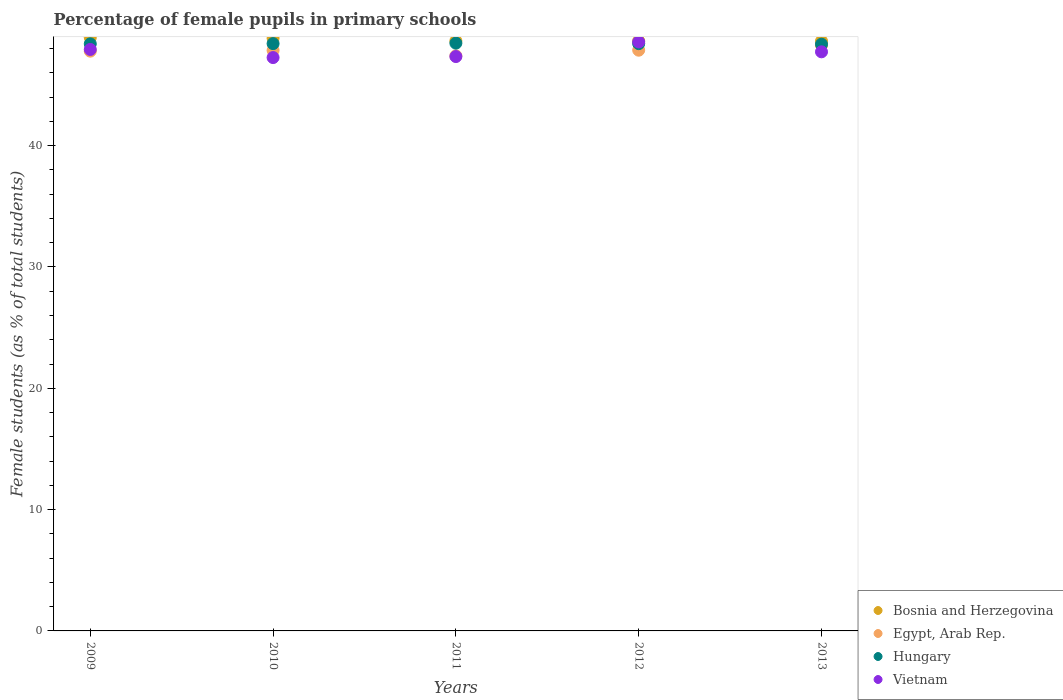How many different coloured dotlines are there?
Ensure brevity in your answer.  4. Is the number of dotlines equal to the number of legend labels?
Keep it short and to the point. Yes. What is the percentage of female pupils in primary schools in Bosnia and Herzegovina in 2012?
Give a very brief answer. 48.63. Across all years, what is the maximum percentage of female pupils in primary schools in Bosnia and Herzegovina?
Your answer should be compact. 48.91. Across all years, what is the minimum percentage of female pupils in primary schools in Bosnia and Herzegovina?
Keep it short and to the point. 48.61. In which year was the percentage of female pupils in primary schools in Egypt, Arab Rep. minimum?
Your answer should be very brief. 2011. What is the total percentage of female pupils in primary schools in Vietnam in the graph?
Your response must be concise. 238.83. What is the difference between the percentage of female pupils in primary schools in Vietnam in 2009 and that in 2011?
Your answer should be compact. 0.59. What is the difference between the percentage of female pupils in primary schools in Hungary in 2013 and the percentage of female pupils in primary schools in Egypt, Arab Rep. in 2009?
Your answer should be compact. 0.57. What is the average percentage of female pupils in primary schools in Egypt, Arab Rep. per year?
Ensure brevity in your answer.  47.84. In the year 2012, what is the difference between the percentage of female pupils in primary schools in Egypt, Arab Rep. and percentage of female pupils in primary schools in Bosnia and Herzegovina?
Ensure brevity in your answer.  -0.76. What is the ratio of the percentage of female pupils in primary schools in Hungary in 2011 to that in 2013?
Your answer should be very brief. 1. Is the percentage of female pupils in primary schools in Egypt, Arab Rep. in 2010 less than that in 2011?
Ensure brevity in your answer.  No. Is the difference between the percentage of female pupils in primary schools in Egypt, Arab Rep. in 2011 and 2013 greater than the difference between the percentage of female pupils in primary schools in Bosnia and Herzegovina in 2011 and 2013?
Give a very brief answer. No. What is the difference between the highest and the second highest percentage of female pupils in primary schools in Egypt, Arab Rep.?
Your answer should be very brief. 0.4. What is the difference between the highest and the lowest percentage of female pupils in primary schools in Egypt, Arab Rep.?
Give a very brief answer. 0.87. Is it the case that in every year, the sum of the percentage of female pupils in primary schools in Bosnia and Herzegovina and percentage of female pupils in primary schools in Egypt, Arab Rep.  is greater than the sum of percentage of female pupils in primary schools in Hungary and percentage of female pupils in primary schools in Vietnam?
Your response must be concise. No. Is it the case that in every year, the sum of the percentage of female pupils in primary schools in Hungary and percentage of female pupils in primary schools in Bosnia and Herzegovina  is greater than the percentage of female pupils in primary schools in Egypt, Arab Rep.?
Offer a terse response. Yes. Is the percentage of female pupils in primary schools in Egypt, Arab Rep. strictly less than the percentage of female pupils in primary schools in Bosnia and Herzegovina over the years?
Your response must be concise. Yes. How many years are there in the graph?
Provide a short and direct response. 5. Are the values on the major ticks of Y-axis written in scientific E-notation?
Offer a terse response. No. Does the graph contain any zero values?
Provide a succinct answer. No. Does the graph contain grids?
Give a very brief answer. No. How are the legend labels stacked?
Ensure brevity in your answer.  Vertical. What is the title of the graph?
Offer a terse response. Percentage of female pupils in primary schools. What is the label or title of the Y-axis?
Offer a very short reply. Female students (as % of total students). What is the Female students (as % of total students) in Bosnia and Herzegovina in 2009?
Ensure brevity in your answer.  48.91. What is the Female students (as % of total students) of Egypt, Arab Rep. in 2009?
Give a very brief answer. 47.79. What is the Female students (as % of total students) in Hungary in 2009?
Provide a short and direct response. 48.39. What is the Female students (as % of total students) of Vietnam in 2009?
Offer a terse response. 47.93. What is the Female students (as % of total students) in Bosnia and Herzegovina in 2010?
Your answer should be very brief. 48.86. What is the Female students (as % of total students) of Egypt, Arab Rep. in 2010?
Ensure brevity in your answer.  47.85. What is the Female students (as % of total students) in Hungary in 2010?
Make the answer very short. 48.41. What is the Female students (as % of total students) of Vietnam in 2010?
Offer a very short reply. 47.26. What is the Female students (as % of total students) of Bosnia and Herzegovina in 2011?
Provide a succinct answer. 48.63. What is the Female students (as % of total students) of Egypt, Arab Rep. in 2011?
Ensure brevity in your answer.  47.4. What is the Female students (as % of total students) in Hungary in 2011?
Ensure brevity in your answer.  48.45. What is the Female students (as % of total students) of Vietnam in 2011?
Provide a short and direct response. 47.35. What is the Female students (as % of total students) in Bosnia and Herzegovina in 2012?
Make the answer very short. 48.63. What is the Female students (as % of total students) of Egypt, Arab Rep. in 2012?
Your response must be concise. 47.87. What is the Female students (as % of total students) in Hungary in 2012?
Provide a short and direct response. 48.41. What is the Female students (as % of total students) in Vietnam in 2012?
Offer a terse response. 48.55. What is the Female students (as % of total students) in Bosnia and Herzegovina in 2013?
Make the answer very short. 48.61. What is the Female students (as % of total students) in Egypt, Arab Rep. in 2013?
Provide a succinct answer. 48.27. What is the Female students (as % of total students) of Hungary in 2013?
Ensure brevity in your answer.  48.36. What is the Female students (as % of total students) in Vietnam in 2013?
Make the answer very short. 47.74. Across all years, what is the maximum Female students (as % of total students) in Bosnia and Herzegovina?
Make the answer very short. 48.91. Across all years, what is the maximum Female students (as % of total students) in Egypt, Arab Rep.?
Provide a succinct answer. 48.27. Across all years, what is the maximum Female students (as % of total students) of Hungary?
Provide a succinct answer. 48.45. Across all years, what is the maximum Female students (as % of total students) in Vietnam?
Ensure brevity in your answer.  48.55. Across all years, what is the minimum Female students (as % of total students) in Bosnia and Herzegovina?
Keep it short and to the point. 48.61. Across all years, what is the minimum Female students (as % of total students) of Egypt, Arab Rep.?
Keep it short and to the point. 47.4. Across all years, what is the minimum Female students (as % of total students) of Hungary?
Keep it short and to the point. 48.36. Across all years, what is the minimum Female students (as % of total students) of Vietnam?
Your response must be concise. 47.26. What is the total Female students (as % of total students) in Bosnia and Herzegovina in the graph?
Your response must be concise. 243.65. What is the total Female students (as % of total students) in Egypt, Arab Rep. in the graph?
Make the answer very short. 239.19. What is the total Female students (as % of total students) of Hungary in the graph?
Provide a short and direct response. 242.03. What is the total Female students (as % of total students) of Vietnam in the graph?
Your response must be concise. 238.83. What is the difference between the Female students (as % of total students) of Bosnia and Herzegovina in 2009 and that in 2010?
Provide a succinct answer. 0.05. What is the difference between the Female students (as % of total students) in Egypt, Arab Rep. in 2009 and that in 2010?
Provide a short and direct response. -0.06. What is the difference between the Female students (as % of total students) of Hungary in 2009 and that in 2010?
Offer a terse response. -0.02. What is the difference between the Female students (as % of total students) in Vietnam in 2009 and that in 2010?
Provide a succinct answer. 0.67. What is the difference between the Female students (as % of total students) in Bosnia and Herzegovina in 2009 and that in 2011?
Offer a terse response. 0.28. What is the difference between the Female students (as % of total students) of Egypt, Arab Rep. in 2009 and that in 2011?
Your answer should be compact. 0.39. What is the difference between the Female students (as % of total students) of Hungary in 2009 and that in 2011?
Your answer should be very brief. -0.06. What is the difference between the Female students (as % of total students) of Vietnam in 2009 and that in 2011?
Offer a very short reply. 0.59. What is the difference between the Female students (as % of total students) in Bosnia and Herzegovina in 2009 and that in 2012?
Your response must be concise. 0.28. What is the difference between the Female students (as % of total students) of Egypt, Arab Rep. in 2009 and that in 2012?
Give a very brief answer. -0.08. What is the difference between the Female students (as % of total students) of Hungary in 2009 and that in 2012?
Provide a succinct answer. -0.02. What is the difference between the Female students (as % of total students) of Vietnam in 2009 and that in 2012?
Keep it short and to the point. -0.62. What is the difference between the Female students (as % of total students) in Bosnia and Herzegovina in 2009 and that in 2013?
Provide a succinct answer. 0.3. What is the difference between the Female students (as % of total students) in Egypt, Arab Rep. in 2009 and that in 2013?
Provide a short and direct response. -0.48. What is the difference between the Female students (as % of total students) in Hungary in 2009 and that in 2013?
Give a very brief answer. 0.03. What is the difference between the Female students (as % of total students) of Vietnam in 2009 and that in 2013?
Keep it short and to the point. 0.2. What is the difference between the Female students (as % of total students) in Bosnia and Herzegovina in 2010 and that in 2011?
Keep it short and to the point. 0.23. What is the difference between the Female students (as % of total students) in Egypt, Arab Rep. in 2010 and that in 2011?
Your response must be concise. 0.45. What is the difference between the Female students (as % of total students) of Hungary in 2010 and that in 2011?
Your answer should be very brief. -0.04. What is the difference between the Female students (as % of total students) in Vietnam in 2010 and that in 2011?
Provide a succinct answer. -0.08. What is the difference between the Female students (as % of total students) of Bosnia and Herzegovina in 2010 and that in 2012?
Offer a very short reply. 0.23. What is the difference between the Female students (as % of total students) in Egypt, Arab Rep. in 2010 and that in 2012?
Give a very brief answer. -0.02. What is the difference between the Female students (as % of total students) of Hungary in 2010 and that in 2012?
Give a very brief answer. 0. What is the difference between the Female students (as % of total students) of Vietnam in 2010 and that in 2012?
Provide a succinct answer. -1.29. What is the difference between the Female students (as % of total students) of Bosnia and Herzegovina in 2010 and that in 2013?
Your answer should be compact. 0.24. What is the difference between the Female students (as % of total students) in Egypt, Arab Rep. in 2010 and that in 2013?
Offer a terse response. -0.42. What is the difference between the Female students (as % of total students) of Hungary in 2010 and that in 2013?
Your response must be concise. 0.05. What is the difference between the Female students (as % of total students) in Vietnam in 2010 and that in 2013?
Offer a very short reply. -0.47. What is the difference between the Female students (as % of total students) of Bosnia and Herzegovina in 2011 and that in 2012?
Give a very brief answer. 0. What is the difference between the Female students (as % of total students) of Egypt, Arab Rep. in 2011 and that in 2012?
Provide a succinct answer. -0.47. What is the difference between the Female students (as % of total students) in Hungary in 2011 and that in 2012?
Provide a succinct answer. 0.04. What is the difference between the Female students (as % of total students) of Vietnam in 2011 and that in 2012?
Your answer should be compact. -1.2. What is the difference between the Female students (as % of total students) in Bosnia and Herzegovina in 2011 and that in 2013?
Your answer should be compact. 0.02. What is the difference between the Female students (as % of total students) of Egypt, Arab Rep. in 2011 and that in 2013?
Your response must be concise. -0.87. What is the difference between the Female students (as % of total students) of Hungary in 2011 and that in 2013?
Your answer should be very brief. 0.09. What is the difference between the Female students (as % of total students) of Vietnam in 2011 and that in 2013?
Offer a terse response. -0.39. What is the difference between the Female students (as % of total students) of Bosnia and Herzegovina in 2012 and that in 2013?
Keep it short and to the point. 0.02. What is the difference between the Female students (as % of total students) in Egypt, Arab Rep. in 2012 and that in 2013?
Offer a terse response. -0.4. What is the difference between the Female students (as % of total students) in Hungary in 2012 and that in 2013?
Your answer should be very brief. 0.05. What is the difference between the Female students (as % of total students) in Vietnam in 2012 and that in 2013?
Your answer should be compact. 0.82. What is the difference between the Female students (as % of total students) of Bosnia and Herzegovina in 2009 and the Female students (as % of total students) of Egypt, Arab Rep. in 2010?
Keep it short and to the point. 1.06. What is the difference between the Female students (as % of total students) in Bosnia and Herzegovina in 2009 and the Female students (as % of total students) in Hungary in 2010?
Offer a terse response. 0.5. What is the difference between the Female students (as % of total students) of Bosnia and Herzegovina in 2009 and the Female students (as % of total students) of Vietnam in 2010?
Make the answer very short. 1.65. What is the difference between the Female students (as % of total students) of Egypt, Arab Rep. in 2009 and the Female students (as % of total students) of Hungary in 2010?
Make the answer very short. -0.62. What is the difference between the Female students (as % of total students) in Egypt, Arab Rep. in 2009 and the Female students (as % of total students) in Vietnam in 2010?
Keep it short and to the point. 0.53. What is the difference between the Female students (as % of total students) in Hungary in 2009 and the Female students (as % of total students) in Vietnam in 2010?
Your answer should be compact. 1.13. What is the difference between the Female students (as % of total students) of Bosnia and Herzegovina in 2009 and the Female students (as % of total students) of Egypt, Arab Rep. in 2011?
Your response must be concise. 1.51. What is the difference between the Female students (as % of total students) of Bosnia and Herzegovina in 2009 and the Female students (as % of total students) of Hungary in 2011?
Your answer should be compact. 0.46. What is the difference between the Female students (as % of total students) in Bosnia and Herzegovina in 2009 and the Female students (as % of total students) in Vietnam in 2011?
Your answer should be compact. 1.56. What is the difference between the Female students (as % of total students) in Egypt, Arab Rep. in 2009 and the Female students (as % of total students) in Hungary in 2011?
Ensure brevity in your answer.  -0.66. What is the difference between the Female students (as % of total students) of Egypt, Arab Rep. in 2009 and the Female students (as % of total students) of Vietnam in 2011?
Offer a very short reply. 0.44. What is the difference between the Female students (as % of total students) in Hungary in 2009 and the Female students (as % of total students) in Vietnam in 2011?
Make the answer very short. 1.05. What is the difference between the Female students (as % of total students) in Bosnia and Herzegovina in 2009 and the Female students (as % of total students) in Egypt, Arab Rep. in 2012?
Provide a short and direct response. 1.04. What is the difference between the Female students (as % of total students) in Bosnia and Herzegovina in 2009 and the Female students (as % of total students) in Hungary in 2012?
Your response must be concise. 0.5. What is the difference between the Female students (as % of total students) of Bosnia and Herzegovina in 2009 and the Female students (as % of total students) of Vietnam in 2012?
Offer a very short reply. 0.36. What is the difference between the Female students (as % of total students) in Egypt, Arab Rep. in 2009 and the Female students (as % of total students) in Hungary in 2012?
Ensure brevity in your answer.  -0.62. What is the difference between the Female students (as % of total students) of Egypt, Arab Rep. in 2009 and the Female students (as % of total students) of Vietnam in 2012?
Offer a very short reply. -0.76. What is the difference between the Female students (as % of total students) of Hungary in 2009 and the Female students (as % of total students) of Vietnam in 2012?
Ensure brevity in your answer.  -0.16. What is the difference between the Female students (as % of total students) of Bosnia and Herzegovina in 2009 and the Female students (as % of total students) of Egypt, Arab Rep. in 2013?
Provide a succinct answer. 0.64. What is the difference between the Female students (as % of total students) in Bosnia and Herzegovina in 2009 and the Female students (as % of total students) in Hungary in 2013?
Provide a short and direct response. 0.55. What is the difference between the Female students (as % of total students) in Bosnia and Herzegovina in 2009 and the Female students (as % of total students) in Vietnam in 2013?
Keep it short and to the point. 1.17. What is the difference between the Female students (as % of total students) in Egypt, Arab Rep. in 2009 and the Female students (as % of total students) in Hungary in 2013?
Provide a succinct answer. -0.57. What is the difference between the Female students (as % of total students) of Egypt, Arab Rep. in 2009 and the Female students (as % of total students) of Vietnam in 2013?
Offer a very short reply. 0.06. What is the difference between the Female students (as % of total students) of Hungary in 2009 and the Female students (as % of total students) of Vietnam in 2013?
Make the answer very short. 0.66. What is the difference between the Female students (as % of total students) of Bosnia and Herzegovina in 2010 and the Female students (as % of total students) of Egypt, Arab Rep. in 2011?
Provide a short and direct response. 1.46. What is the difference between the Female students (as % of total students) in Bosnia and Herzegovina in 2010 and the Female students (as % of total students) in Hungary in 2011?
Give a very brief answer. 0.41. What is the difference between the Female students (as % of total students) in Bosnia and Herzegovina in 2010 and the Female students (as % of total students) in Vietnam in 2011?
Offer a terse response. 1.51. What is the difference between the Female students (as % of total students) of Egypt, Arab Rep. in 2010 and the Female students (as % of total students) of Hungary in 2011?
Keep it short and to the point. -0.6. What is the difference between the Female students (as % of total students) in Egypt, Arab Rep. in 2010 and the Female students (as % of total students) in Vietnam in 2011?
Give a very brief answer. 0.51. What is the difference between the Female students (as % of total students) in Hungary in 2010 and the Female students (as % of total students) in Vietnam in 2011?
Provide a short and direct response. 1.07. What is the difference between the Female students (as % of total students) in Bosnia and Herzegovina in 2010 and the Female students (as % of total students) in Egypt, Arab Rep. in 2012?
Your answer should be very brief. 0.99. What is the difference between the Female students (as % of total students) of Bosnia and Herzegovina in 2010 and the Female students (as % of total students) of Hungary in 2012?
Keep it short and to the point. 0.45. What is the difference between the Female students (as % of total students) of Bosnia and Herzegovina in 2010 and the Female students (as % of total students) of Vietnam in 2012?
Your answer should be very brief. 0.31. What is the difference between the Female students (as % of total students) of Egypt, Arab Rep. in 2010 and the Female students (as % of total students) of Hungary in 2012?
Give a very brief answer. -0.56. What is the difference between the Female students (as % of total students) in Egypt, Arab Rep. in 2010 and the Female students (as % of total students) in Vietnam in 2012?
Your answer should be very brief. -0.7. What is the difference between the Female students (as % of total students) in Hungary in 2010 and the Female students (as % of total students) in Vietnam in 2012?
Ensure brevity in your answer.  -0.14. What is the difference between the Female students (as % of total students) in Bosnia and Herzegovina in 2010 and the Female students (as % of total students) in Egypt, Arab Rep. in 2013?
Your response must be concise. 0.59. What is the difference between the Female students (as % of total students) in Bosnia and Herzegovina in 2010 and the Female students (as % of total students) in Hungary in 2013?
Make the answer very short. 0.49. What is the difference between the Female students (as % of total students) in Bosnia and Herzegovina in 2010 and the Female students (as % of total students) in Vietnam in 2013?
Your answer should be compact. 1.12. What is the difference between the Female students (as % of total students) of Egypt, Arab Rep. in 2010 and the Female students (as % of total students) of Hungary in 2013?
Ensure brevity in your answer.  -0.51. What is the difference between the Female students (as % of total students) of Egypt, Arab Rep. in 2010 and the Female students (as % of total students) of Vietnam in 2013?
Offer a very short reply. 0.12. What is the difference between the Female students (as % of total students) of Hungary in 2010 and the Female students (as % of total students) of Vietnam in 2013?
Your answer should be very brief. 0.68. What is the difference between the Female students (as % of total students) of Bosnia and Herzegovina in 2011 and the Female students (as % of total students) of Egypt, Arab Rep. in 2012?
Offer a terse response. 0.76. What is the difference between the Female students (as % of total students) in Bosnia and Herzegovina in 2011 and the Female students (as % of total students) in Hungary in 2012?
Keep it short and to the point. 0.22. What is the difference between the Female students (as % of total students) of Bosnia and Herzegovina in 2011 and the Female students (as % of total students) of Vietnam in 2012?
Provide a succinct answer. 0.08. What is the difference between the Female students (as % of total students) in Egypt, Arab Rep. in 2011 and the Female students (as % of total students) in Hungary in 2012?
Offer a terse response. -1.01. What is the difference between the Female students (as % of total students) in Egypt, Arab Rep. in 2011 and the Female students (as % of total students) in Vietnam in 2012?
Offer a terse response. -1.15. What is the difference between the Female students (as % of total students) of Hungary in 2011 and the Female students (as % of total students) of Vietnam in 2012?
Ensure brevity in your answer.  -0.1. What is the difference between the Female students (as % of total students) in Bosnia and Herzegovina in 2011 and the Female students (as % of total students) in Egypt, Arab Rep. in 2013?
Ensure brevity in your answer.  0.36. What is the difference between the Female students (as % of total students) of Bosnia and Herzegovina in 2011 and the Female students (as % of total students) of Hungary in 2013?
Provide a succinct answer. 0.27. What is the difference between the Female students (as % of total students) in Bosnia and Herzegovina in 2011 and the Female students (as % of total students) in Vietnam in 2013?
Give a very brief answer. 0.9. What is the difference between the Female students (as % of total students) in Egypt, Arab Rep. in 2011 and the Female students (as % of total students) in Hungary in 2013?
Your answer should be very brief. -0.96. What is the difference between the Female students (as % of total students) of Egypt, Arab Rep. in 2011 and the Female students (as % of total students) of Vietnam in 2013?
Ensure brevity in your answer.  -0.33. What is the difference between the Female students (as % of total students) of Hungary in 2011 and the Female students (as % of total students) of Vietnam in 2013?
Ensure brevity in your answer.  0.71. What is the difference between the Female students (as % of total students) of Bosnia and Herzegovina in 2012 and the Female students (as % of total students) of Egypt, Arab Rep. in 2013?
Provide a short and direct response. 0.36. What is the difference between the Female students (as % of total students) of Bosnia and Herzegovina in 2012 and the Female students (as % of total students) of Hungary in 2013?
Offer a very short reply. 0.27. What is the difference between the Female students (as % of total students) of Bosnia and Herzegovina in 2012 and the Female students (as % of total students) of Vietnam in 2013?
Keep it short and to the point. 0.89. What is the difference between the Female students (as % of total students) in Egypt, Arab Rep. in 2012 and the Female students (as % of total students) in Hungary in 2013?
Provide a short and direct response. -0.49. What is the difference between the Female students (as % of total students) of Egypt, Arab Rep. in 2012 and the Female students (as % of total students) of Vietnam in 2013?
Provide a short and direct response. 0.13. What is the difference between the Female students (as % of total students) in Hungary in 2012 and the Female students (as % of total students) in Vietnam in 2013?
Ensure brevity in your answer.  0.67. What is the average Female students (as % of total students) in Bosnia and Herzegovina per year?
Ensure brevity in your answer.  48.73. What is the average Female students (as % of total students) of Egypt, Arab Rep. per year?
Keep it short and to the point. 47.84. What is the average Female students (as % of total students) of Hungary per year?
Provide a succinct answer. 48.41. What is the average Female students (as % of total students) of Vietnam per year?
Provide a short and direct response. 47.77. In the year 2009, what is the difference between the Female students (as % of total students) in Bosnia and Herzegovina and Female students (as % of total students) in Egypt, Arab Rep.?
Your answer should be very brief. 1.12. In the year 2009, what is the difference between the Female students (as % of total students) of Bosnia and Herzegovina and Female students (as % of total students) of Hungary?
Your answer should be very brief. 0.52. In the year 2009, what is the difference between the Female students (as % of total students) of Bosnia and Herzegovina and Female students (as % of total students) of Vietnam?
Your answer should be compact. 0.98. In the year 2009, what is the difference between the Female students (as % of total students) in Egypt, Arab Rep. and Female students (as % of total students) in Hungary?
Offer a very short reply. -0.6. In the year 2009, what is the difference between the Female students (as % of total students) in Egypt, Arab Rep. and Female students (as % of total students) in Vietnam?
Give a very brief answer. -0.14. In the year 2009, what is the difference between the Female students (as % of total students) in Hungary and Female students (as % of total students) in Vietnam?
Offer a terse response. 0.46. In the year 2010, what is the difference between the Female students (as % of total students) of Bosnia and Herzegovina and Female students (as % of total students) of Egypt, Arab Rep.?
Provide a succinct answer. 1.01. In the year 2010, what is the difference between the Female students (as % of total students) of Bosnia and Herzegovina and Female students (as % of total students) of Hungary?
Offer a very short reply. 0.45. In the year 2010, what is the difference between the Female students (as % of total students) of Bosnia and Herzegovina and Female students (as % of total students) of Vietnam?
Ensure brevity in your answer.  1.6. In the year 2010, what is the difference between the Female students (as % of total students) in Egypt, Arab Rep. and Female students (as % of total students) in Hungary?
Your response must be concise. -0.56. In the year 2010, what is the difference between the Female students (as % of total students) in Egypt, Arab Rep. and Female students (as % of total students) in Vietnam?
Your answer should be compact. 0.59. In the year 2010, what is the difference between the Female students (as % of total students) of Hungary and Female students (as % of total students) of Vietnam?
Ensure brevity in your answer.  1.15. In the year 2011, what is the difference between the Female students (as % of total students) in Bosnia and Herzegovina and Female students (as % of total students) in Egypt, Arab Rep.?
Ensure brevity in your answer.  1.23. In the year 2011, what is the difference between the Female students (as % of total students) in Bosnia and Herzegovina and Female students (as % of total students) in Hungary?
Offer a terse response. 0.18. In the year 2011, what is the difference between the Female students (as % of total students) of Bosnia and Herzegovina and Female students (as % of total students) of Vietnam?
Keep it short and to the point. 1.29. In the year 2011, what is the difference between the Female students (as % of total students) of Egypt, Arab Rep. and Female students (as % of total students) of Hungary?
Offer a very short reply. -1.05. In the year 2011, what is the difference between the Female students (as % of total students) of Egypt, Arab Rep. and Female students (as % of total students) of Vietnam?
Keep it short and to the point. 0.06. In the year 2011, what is the difference between the Female students (as % of total students) in Hungary and Female students (as % of total students) in Vietnam?
Provide a short and direct response. 1.1. In the year 2012, what is the difference between the Female students (as % of total students) of Bosnia and Herzegovina and Female students (as % of total students) of Egypt, Arab Rep.?
Offer a very short reply. 0.76. In the year 2012, what is the difference between the Female students (as % of total students) of Bosnia and Herzegovina and Female students (as % of total students) of Hungary?
Keep it short and to the point. 0.22. In the year 2012, what is the difference between the Female students (as % of total students) of Bosnia and Herzegovina and Female students (as % of total students) of Vietnam?
Your response must be concise. 0.08. In the year 2012, what is the difference between the Female students (as % of total students) of Egypt, Arab Rep. and Female students (as % of total students) of Hungary?
Your answer should be very brief. -0.54. In the year 2012, what is the difference between the Female students (as % of total students) of Egypt, Arab Rep. and Female students (as % of total students) of Vietnam?
Provide a short and direct response. -0.68. In the year 2012, what is the difference between the Female students (as % of total students) of Hungary and Female students (as % of total students) of Vietnam?
Make the answer very short. -0.14. In the year 2013, what is the difference between the Female students (as % of total students) of Bosnia and Herzegovina and Female students (as % of total students) of Egypt, Arab Rep.?
Make the answer very short. 0.34. In the year 2013, what is the difference between the Female students (as % of total students) in Bosnia and Herzegovina and Female students (as % of total students) in Hungary?
Make the answer very short. 0.25. In the year 2013, what is the difference between the Female students (as % of total students) in Bosnia and Herzegovina and Female students (as % of total students) in Vietnam?
Make the answer very short. 0.88. In the year 2013, what is the difference between the Female students (as % of total students) of Egypt, Arab Rep. and Female students (as % of total students) of Hungary?
Offer a terse response. -0.09. In the year 2013, what is the difference between the Female students (as % of total students) in Egypt, Arab Rep. and Female students (as % of total students) in Vietnam?
Offer a terse response. 0.54. In the year 2013, what is the difference between the Female students (as % of total students) of Hungary and Female students (as % of total students) of Vietnam?
Your answer should be very brief. 0.63. What is the ratio of the Female students (as % of total students) of Bosnia and Herzegovina in 2009 to that in 2010?
Give a very brief answer. 1. What is the ratio of the Female students (as % of total students) in Egypt, Arab Rep. in 2009 to that in 2010?
Your response must be concise. 1. What is the ratio of the Female students (as % of total students) in Vietnam in 2009 to that in 2010?
Your answer should be compact. 1.01. What is the ratio of the Female students (as % of total students) of Egypt, Arab Rep. in 2009 to that in 2011?
Offer a very short reply. 1.01. What is the ratio of the Female students (as % of total students) of Vietnam in 2009 to that in 2011?
Keep it short and to the point. 1.01. What is the ratio of the Female students (as % of total students) of Hungary in 2009 to that in 2012?
Offer a terse response. 1. What is the ratio of the Female students (as % of total students) in Vietnam in 2009 to that in 2012?
Offer a very short reply. 0.99. What is the ratio of the Female students (as % of total students) of Egypt, Arab Rep. in 2009 to that in 2013?
Give a very brief answer. 0.99. What is the ratio of the Female students (as % of total students) of Vietnam in 2009 to that in 2013?
Your response must be concise. 1. What is the ratio of the Female students (as % of total students) in Bosnia and Herzegovina in 2010 to that in 2011?
Your response must be concise. 1. What is the ratio of the Female students (as % of total students) of Egypt, Arab Rep. in 2010 to that in 2011?
Ensure brevity in your answer.  1.01. What is the ratio of the Female students (as % of total students) in Hungary in 2010 to that in 2011?
Provide a succinct answer. 1. What is the ratio of the Female students (as % of total students) of Bosnia and Herzegovina in 2010 to that in 2012?
Give a very brief answer. 1. What is the ratio of the Female students (as % of total students) of Egypt, Arab Rep. in 2010 to that in 2012?
Provide a short and direct response. 1. What is the ratio of the Female students (as % of total students) in Vietnam in 2010 to that in 2012?
Provide a succinct answer. 0.97. What is the ratio of the Female students (as % of total students) of Egypt, Arab Rep. in 2010 to that in 2013?
Provide a succinct answer. 0.99. What is the ratio of the Female students (as % of total students) in Vietnam in 2010 to that in 2013?
Offer a terse response. 0.99. What is the ratio of the Female students (as % of total students) in Bosnia and Herzegovina in 2011 to that in 2012?
Make the answer very short. 1. What is the ratio of the Female students (as % of total students) of Egypt, Arab Rep. in 2011 to that in 2012?
Give a very brief answer. 0.99. What is the ratio of the Female students (as % of total students) in Hungary in 2011 to that in 2012?
Provide a succinct answer. 1. What is the ratio of the Female students (as % of total students) in Vietnam in 2011 to that in 2012?
Your answer should be compact. 0.98. What is the ratio of the Female students (as % of total students) in Bosnia and Herzegovina in 2011 to that in 2013?
Provide a short and direct response. 1. What is the ratio of the Female students (as % of total students) in Hungary in 2011 to that in 2013?
Keep it short and to the point. 1. What is the ratio of the Female students (as % of total students) of Vietnam in 2012 to that in 2013?
Your answer should be compact. 1.02. What is the difference between the highest and the second highest Female students (as % of total students) in Bosnia and Herzegovina?
Provide a succinct answer. 0.05. What is the difference between the highest and the second highest Female students (as % of total students) of Egypt, Arab Rep.?
Provide a succinct answer. 0.4. What is the difference between the highest and the second highest Female students (as % of total students) of Hungary?
Your answer should be compact. 0.04. What is the difference between the highest and the second highest Female students (as % of total students) of Vietnam?
Your response must be concise. 0.62. What is the difference between the highest and the lowest Female students (as % of total students) in Bosnia and Herzegovina?
Give a very brief answer. 0.3. What is the difference between the highest and the lowest Female students (as % of total students) of Egypt, Arab Rep.?
Ensure brevity in your answer.  0.87. What is the difference between the highest and the lowest Female students (as % of total students) of Hungary?
Your answer should be very brief. 0.09. What is the difference between the highest and the lowest Female students (as % of total students) in Vietnam?
Offer a terse response. 1.29. 